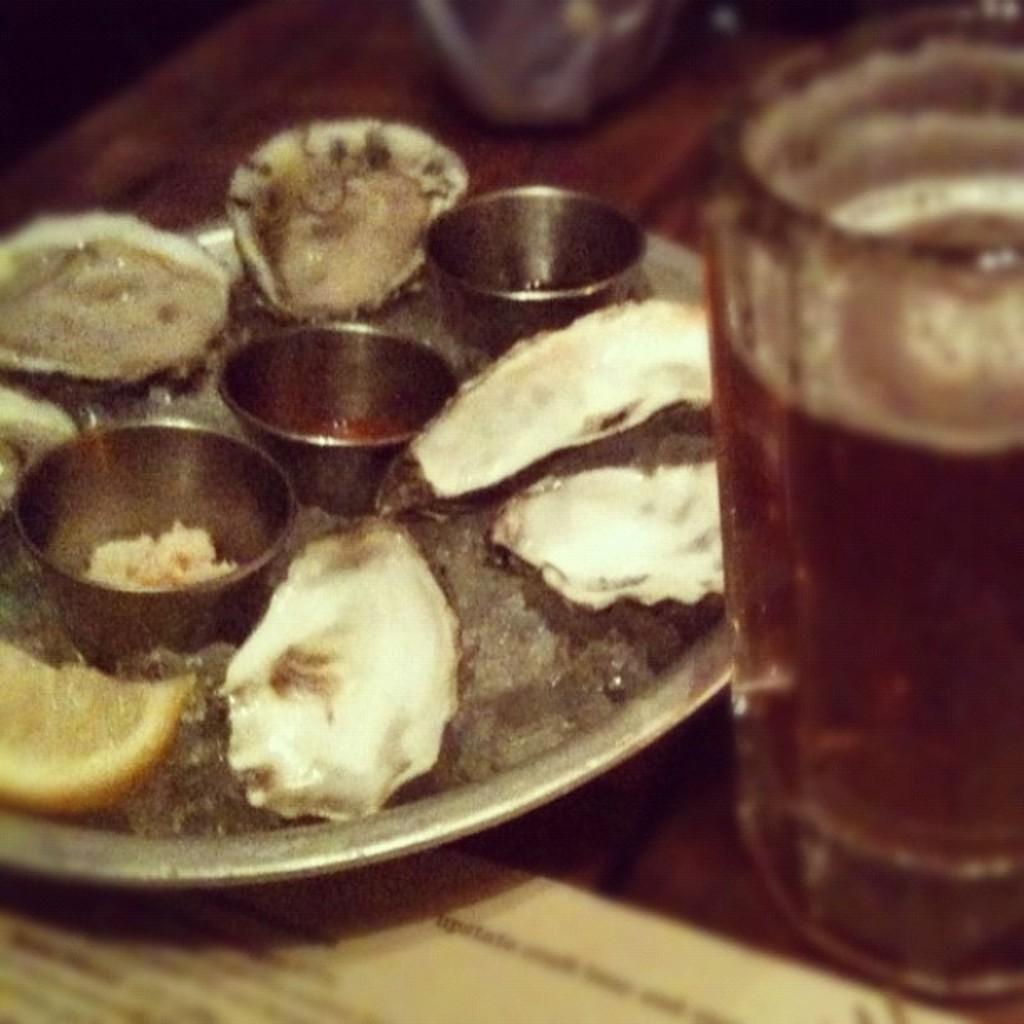Can you describe this image briefly? This is the table. I can see a plate, which contains food and small bowls. Here is the glass. I think this is the paper. 